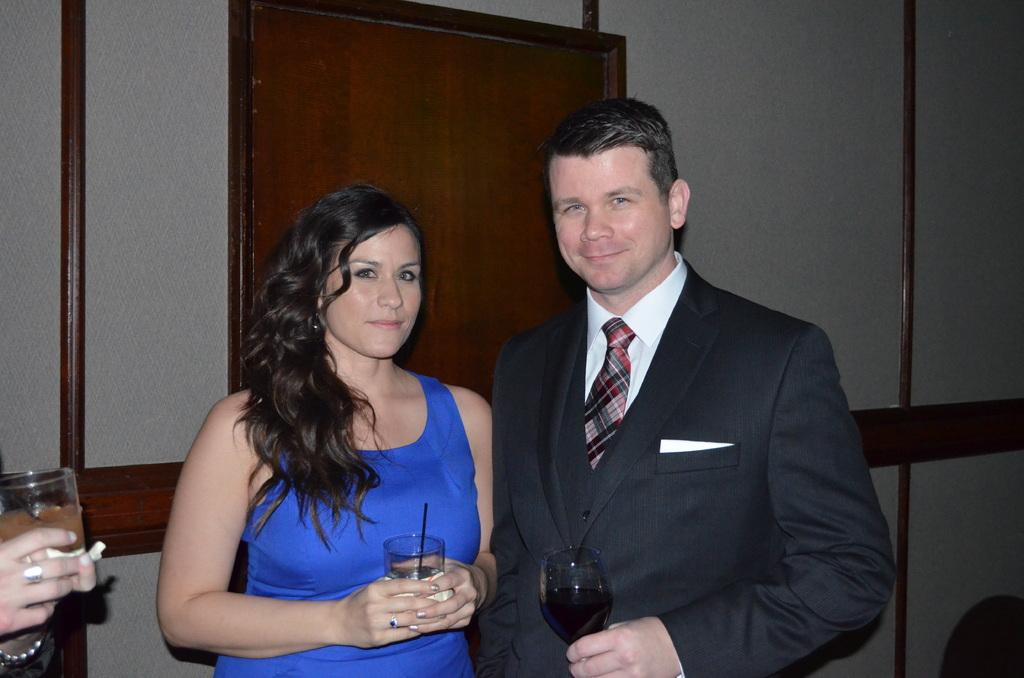Who are the two people in the center of the image? There is a man and a woman in the center of the image. What are the man and woman doing in the image? The man and woman are standing and holding glass tumblers. What can be seen in the background of the image? There is a door and a wall in the background of the image. What type of ghost can be seen interacting with the man and woman in the image? There is no ghost present in the image; it only features a man and a woman holding glass tumblers. What type of stem is visible on the man's glass tumbler in the image? The image does not show any stems on the glass tumblers, as they are not visible in the image. 